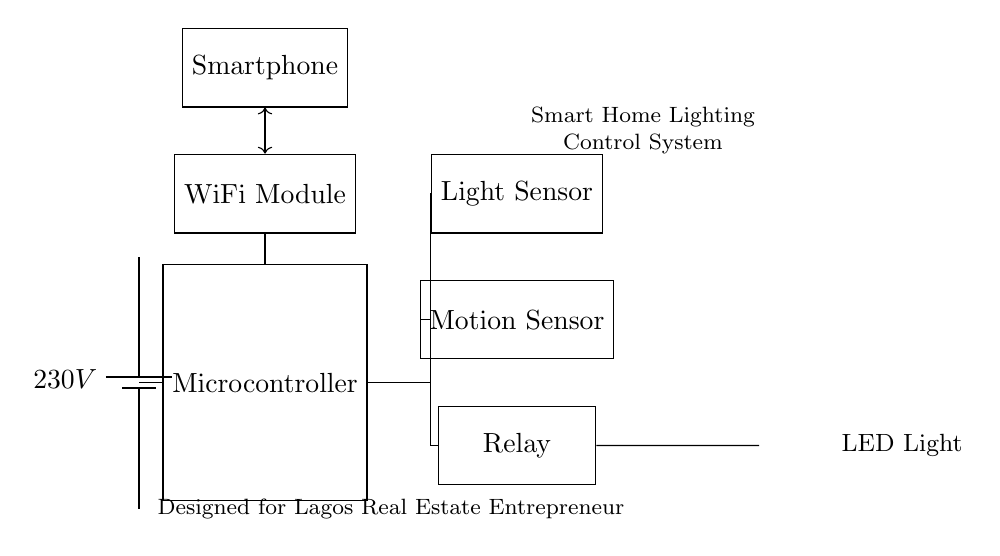What is the main voltage supply for this circuit? The main voltage supply is labeled as 230V, indicating the power provided to the system from the battery.
Answer: 230V What component detects light levels? The circuit diagram includes a "Light Sensor" component, which is responsible for detecting ambient light levels in the environment.
Answer: Light Sensor Which component is used to control the lighting? The "Relay" is the component that controls the lighting by turning the LED light on and off based on signals it receives.
Answer: Relay How many sensors are present in the diagram? There are two sensors present: a Light Sensor and a Motion Sensor, which contribute to the automated control of lighting.
Answer: 2 What does the smartphone connect to in this circuit? The smartphone connects to the WiFi Module via a two-way communication link, allowing remote control of the lighting system.
Answer: WiFi Module What is the function of the microcontroller in this circuit? The microcontroller acts as the central processing unit that interprets data from the sensors and controls the relays to manage the lighting according to the detected conditions.
Answer: Central processing unit How does the microcontroller receive information from the sensors? The microcontroller receives input from both the Light Sensor and the Motion Sensor, using their outputs to make decisions about the lighting state based on environmental conditions.
Answer: Inputs from sensors 